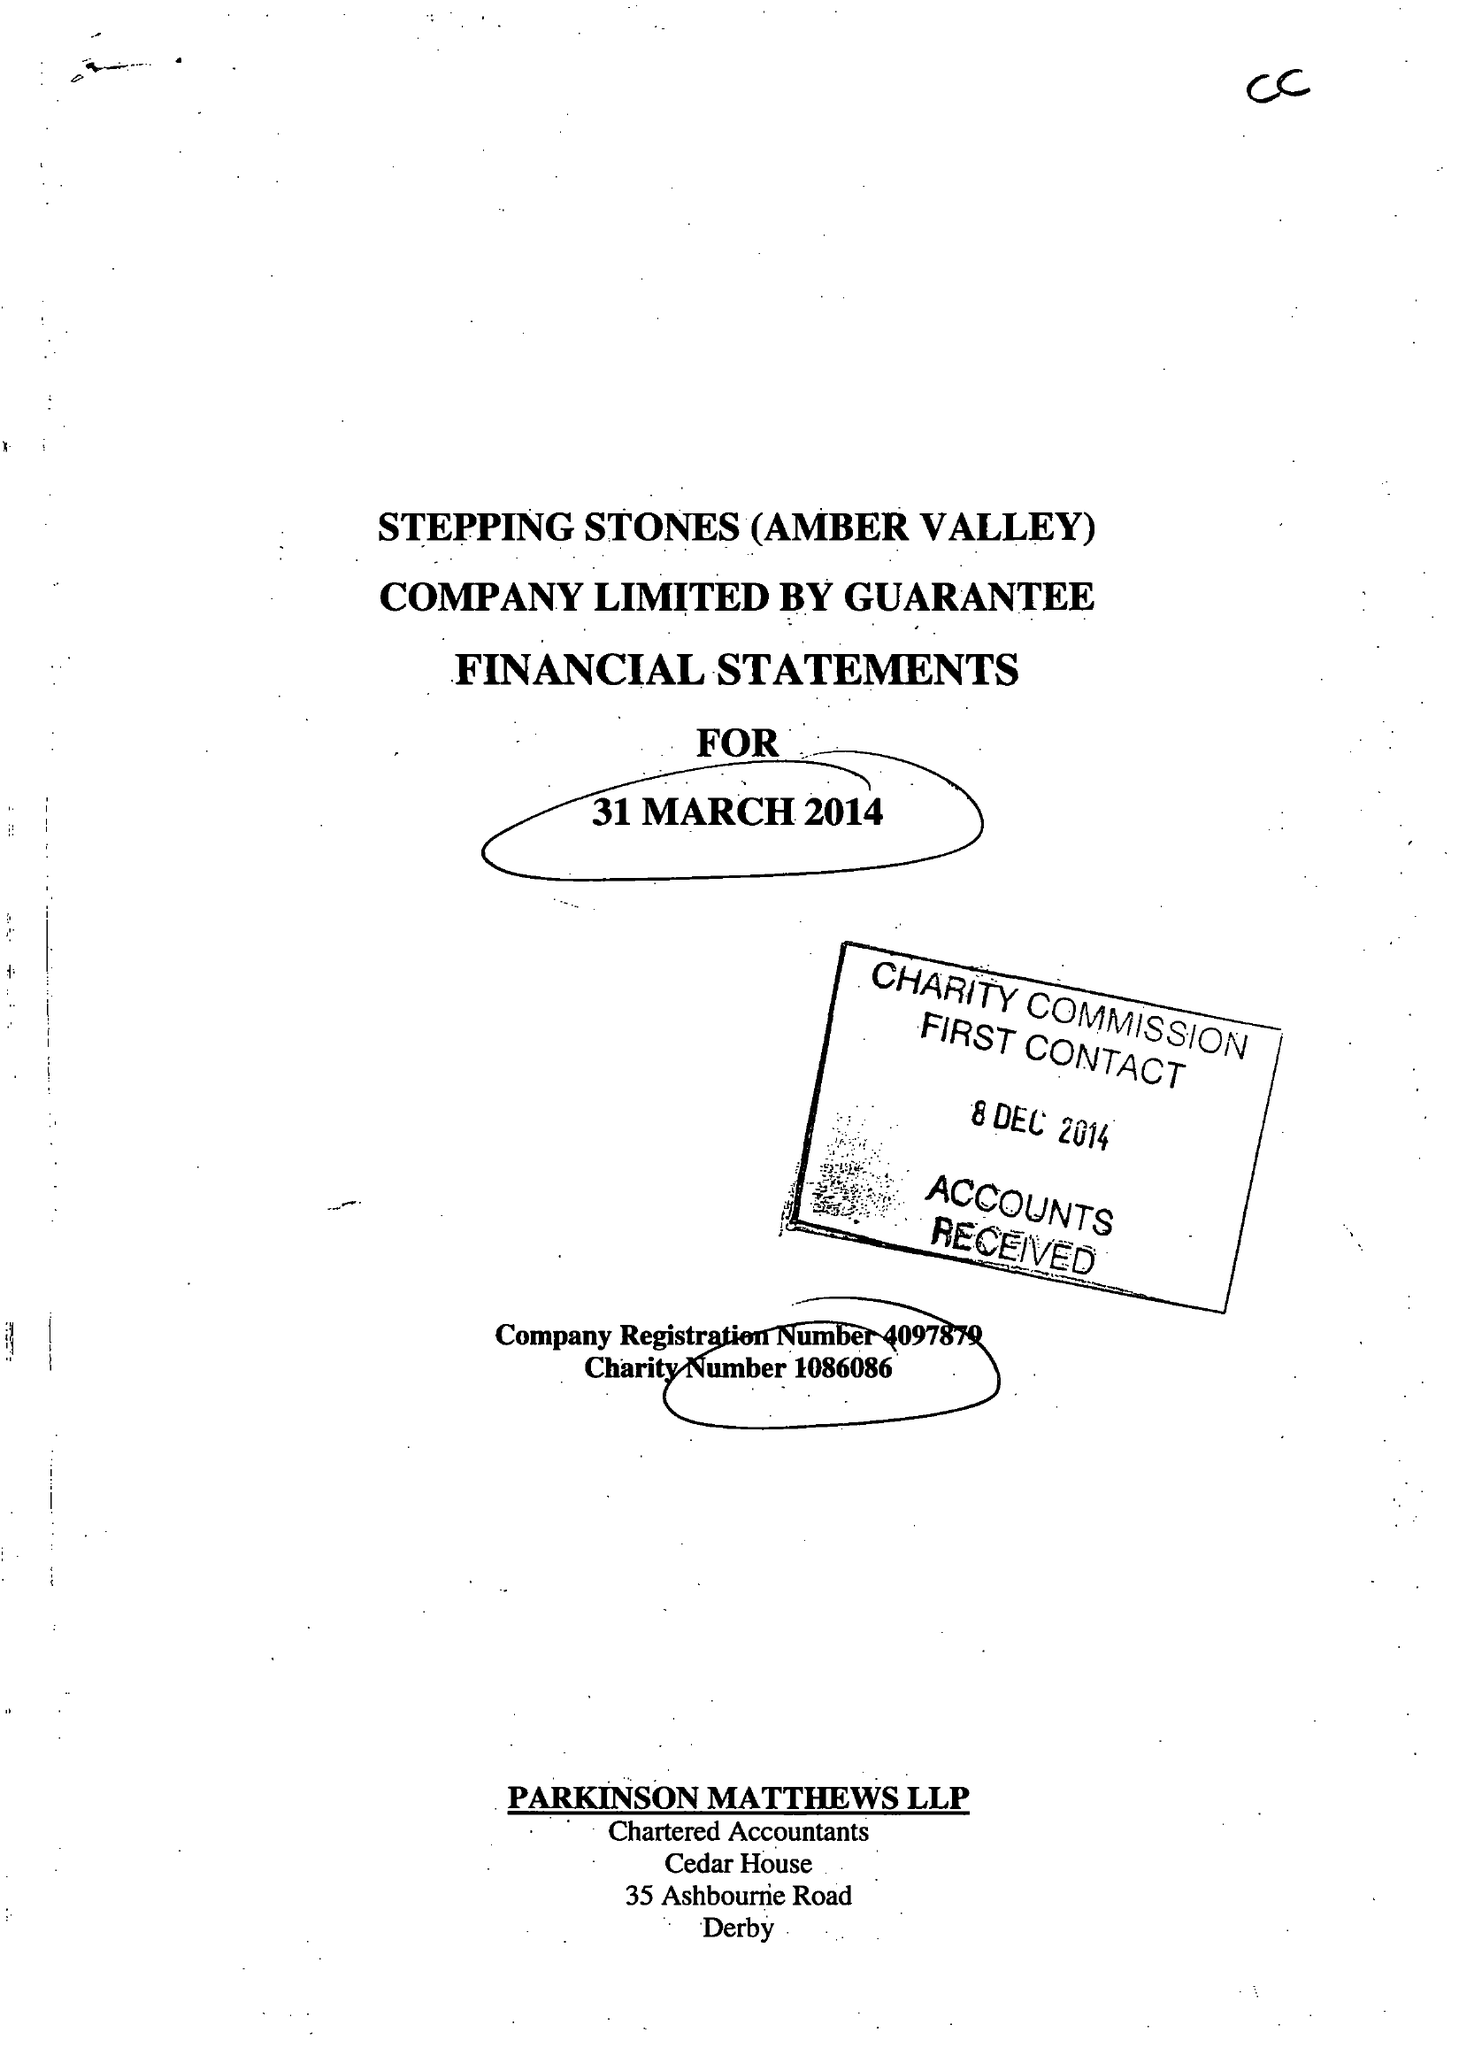What is the value for the income_annually_in_british_pounds?
Answer the question using a single word or phrase. 117499.00 